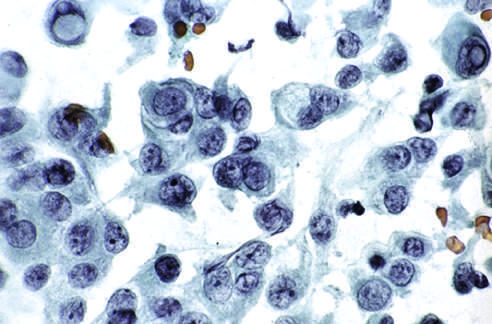what is obtained by fine-needle aspiration of a papillary carcinoma?
Answer the question using a single word or phrase. Cells 